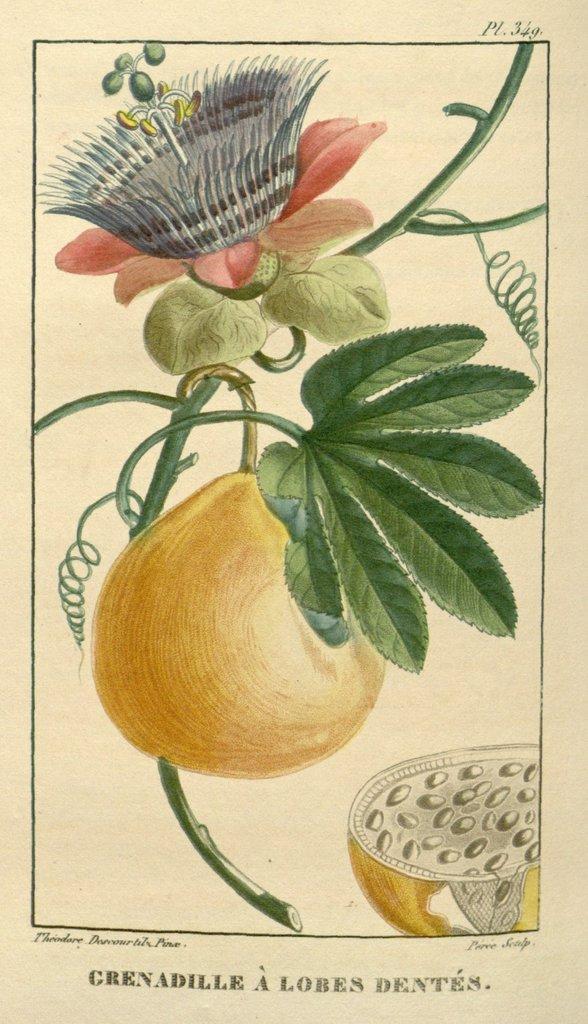Can you describe this image briefly? This is a paper. This is a painting. In this picture we can see the fruits, leaf, flower. At the bottom of the image we can see the text. 